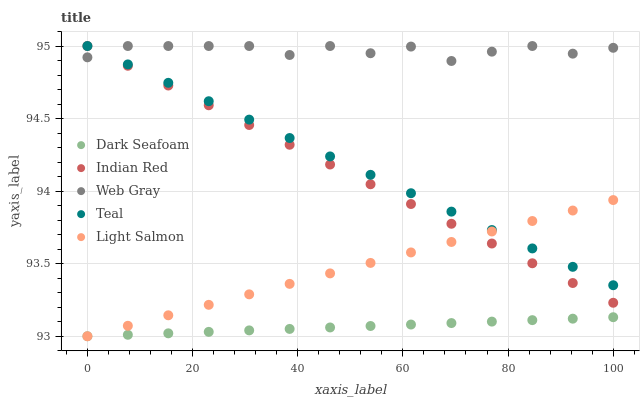Does Dark Seafoam have the minimum area under the curve?
Answer yes or no. Yes. Does Web Gray have the maximum area under the curve?
Answer yes or no. Yes. Does Teal have the minimum area under the curve?
Answer yes or no. No. Does Teal have the maximum area under the curve?
Answer yes or no. No. Is Dark Seafoam the smoothest?
Answer yes or no. Yes. Is Web Gray the roughest?
Answer yes or no. Yes. Is Teal the smoothest?
Answer yes or no. No. Is Teal the roughest?
Answer yes or no. No. Does Dark Seafoam have the lowest value?
Answer yes or no. Yes. Does Teal have the lowest value?
Answer yes or no. No. Does Indian Red have the highest value?
Answer yes or no. Yes. Does Light Salmon have the highest value?
Answer yes or no. No. Is Dark Seafoam less than Indian Red?
Answer yes or no. Yes. Is Teal greater than Dark Seafoam?
Answer yes or no. Yes. Does Web Gray intersect Teal?
Answer yes or no. Yes. Is Web Gray less than Teal?
Answer yes or no. No. Is Web Gray greater than Teal?
Answer yes or no. No. Does Dark Seafoam intersect Indian Red?
Answer yes or no. No. 